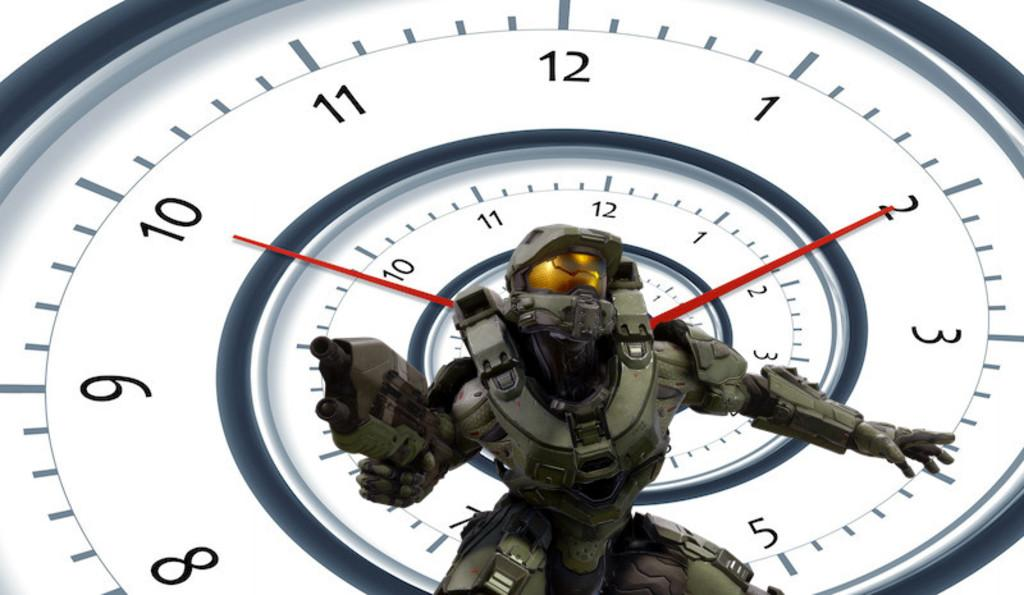<image>
Present a compact description of the photo's key features. A large white clock indicates that it is ten after ten. 